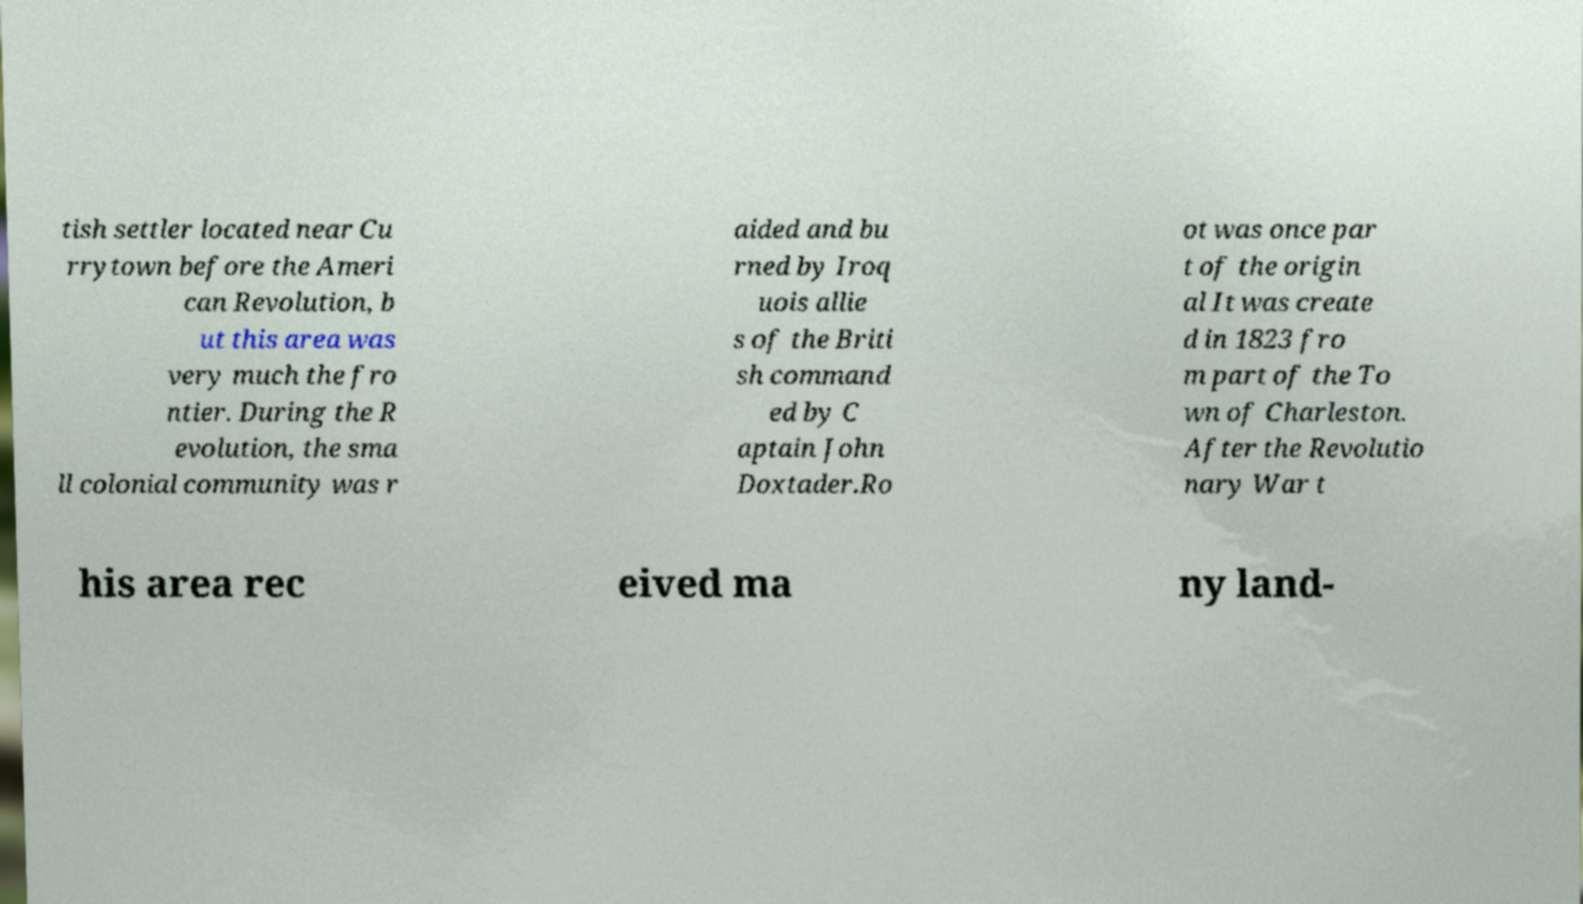Could you extract and type out the text from this image? tish settler located near Cu rrytown before the Ameri can Revolution, b ut this area was very much the fro ntier. During the R evolution, the sma ll colonial community was r aided and bu rned by Iroq uois allie s of the Briti sh command ed by C aptain John Doxtader.Ro ot was once par t of the origin al It was create d in 1823 fro m part of the To wn of Charleston. After the Revolutio nary War t his area rec eived ma ny land- 